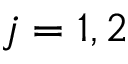<formula> <loc_0><loc_0><loc_500><loc_500>j = 1 , 2</formula> 